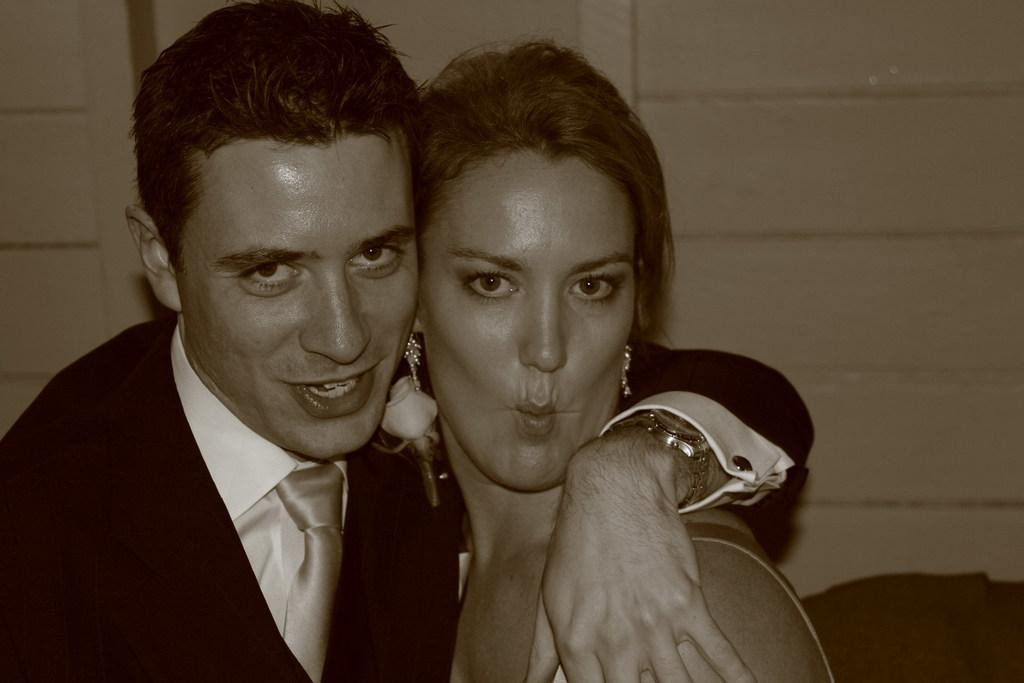How many people are in the image? There are two people in the image, a man and a woman. What is the man wearing in the image? The man is wearing a watch in the image. What is the color scheme of the image? The image is black and white. What can be seen in the background of the image? There is a wall in the background of the image. What type of force is being applied by the man in the image? There is no indication of any force being applied by the man in the image. What kind of apparel is the woman wearing in the image? The provided facts do not mention any specific apparel worn by the woman in the image. 